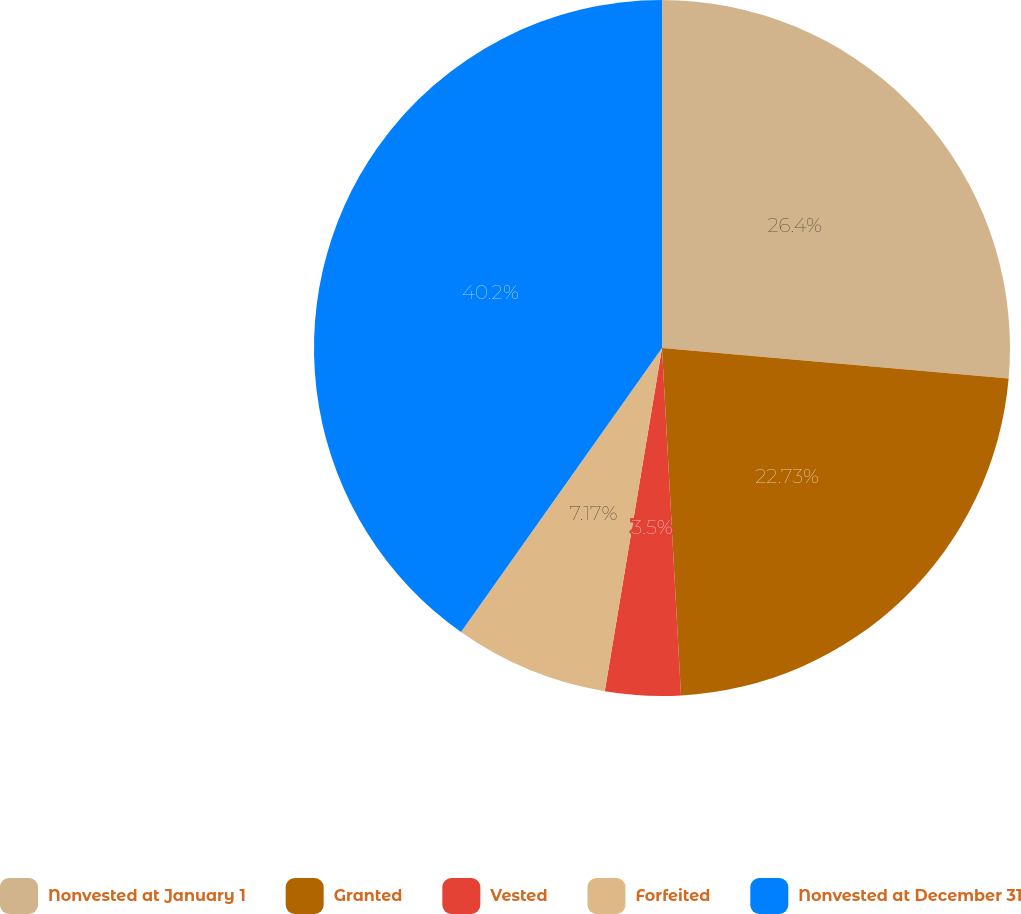Convert chart to OTSL. <chart><loc_0><loc_0><loc_500><loc_500><pie_chart><fcel>Nonvested at January 1<fcel>Granted<fcel>Vested<fcel>Forfeited<fcel>Nonvested at December 31<nl><fcel>26.4%<fcel>22.73%<fcel>3.5%<fcel>7.17%<fcel>40.2%<nl></chart> 